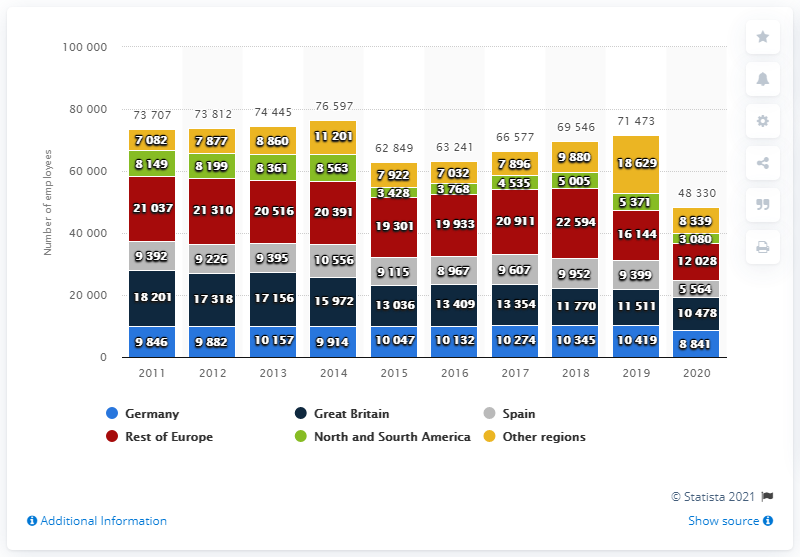Mention a couple of crucial points in this snapshot. In 2020, TUI AG employed 5,564 people in Spain. In 2019, TUI AG employed 9,399 people in Spain. 